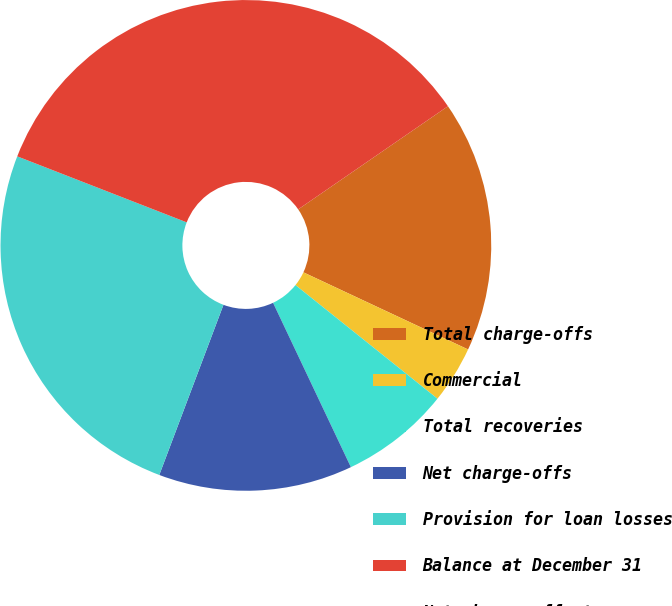Convert chart. <chart><loc_0><loc_0><loc_500><loc_500><pie_chart><fcel>Total charge-offs<fcel>Commercial<fcel>Total recoveries<fcel>Net charge-offs<fcel>Provision for loan losses<fcel>Balance at December 31<fcel>Net charge-offs to average<nl><fcel>16.57%<fcel>3.77%<fcel>7.22%<fcel>12.78%<fcel>25.17%<fcel>34.49%<fcel>0.0%<nl></chart> 